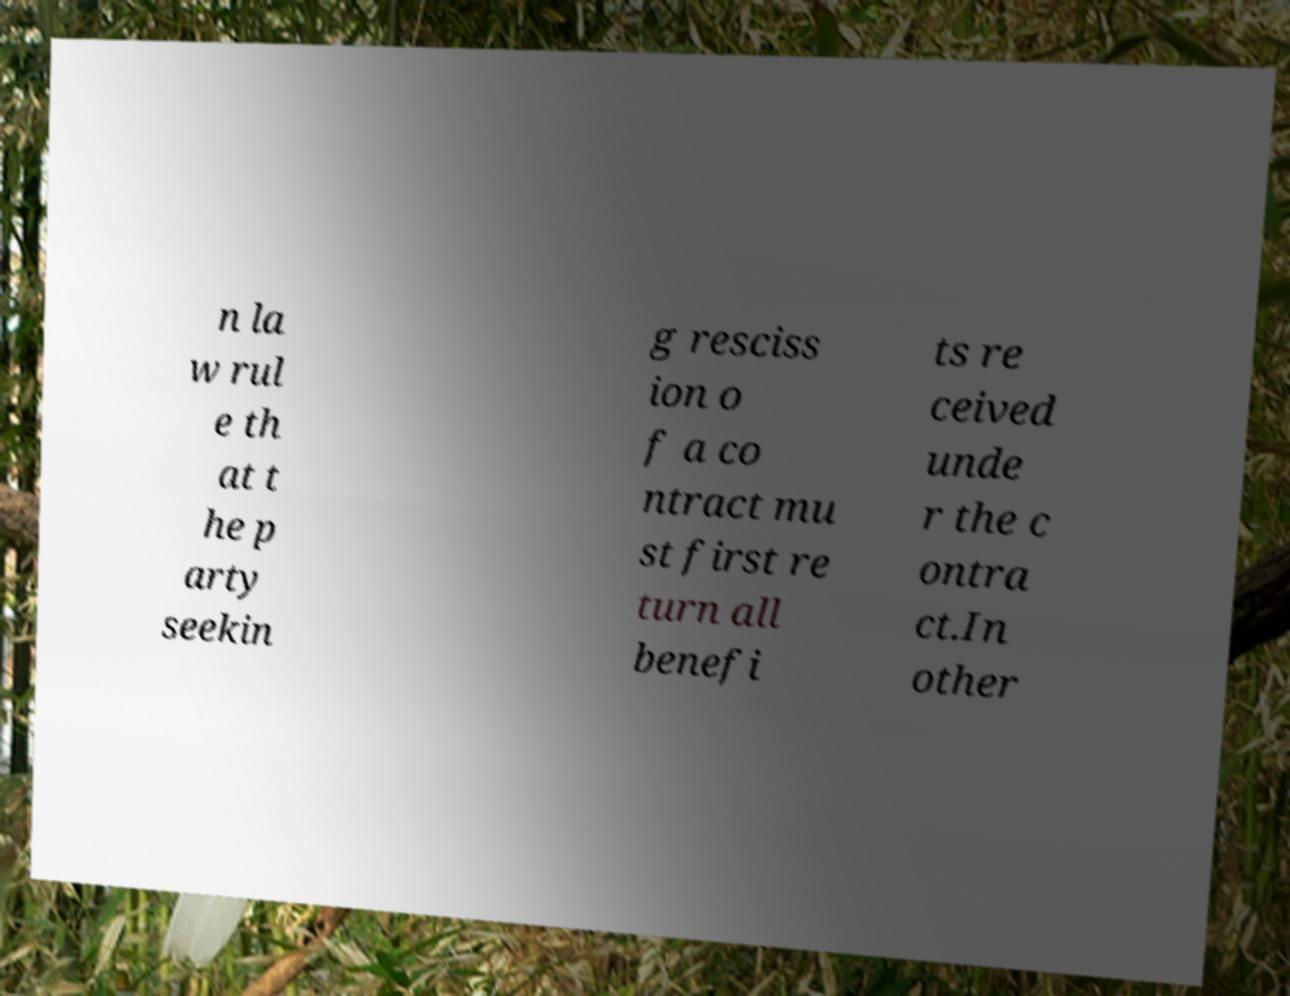Can you read and provide the text displayed in the image?This photo seems to have some interesting text. Can you extract and type it out for me? n la w rul e th at t he p arty seekin g resciss ion o f a co ntract mu st first re turn all benefi ts re ceived unde r the c ontra ct.In other 